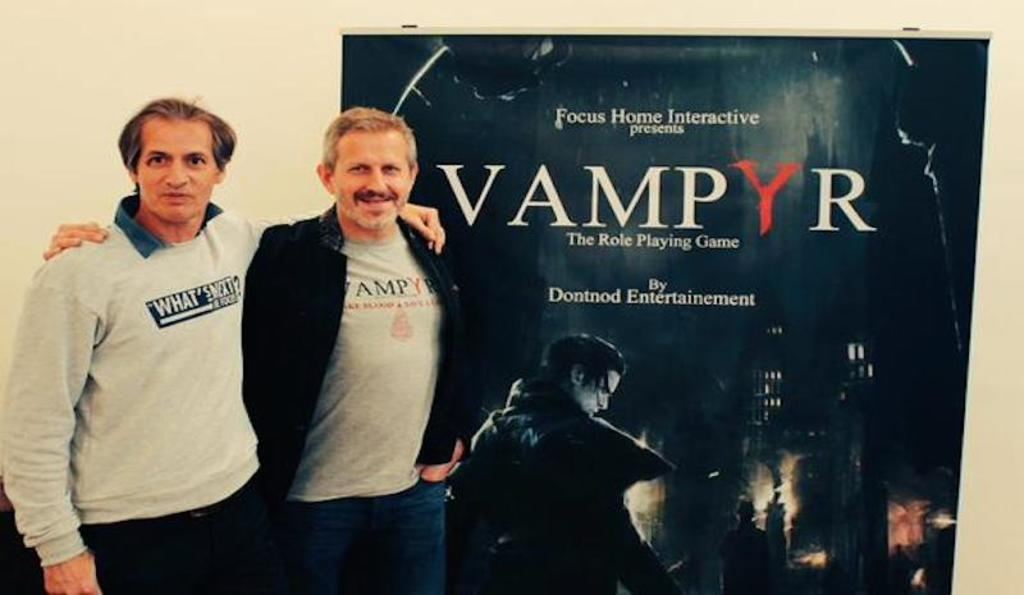How many people are in the image? There are two persons standing in the image. What object can be seen in the image besides the people? There is a board in the image. What is visible in the background of the image? There is a wall in the background of the image. What type of brass instrument is being played by the person on the left in the image? There is no brass instrument present in the image; only two persons and a board are visible. 